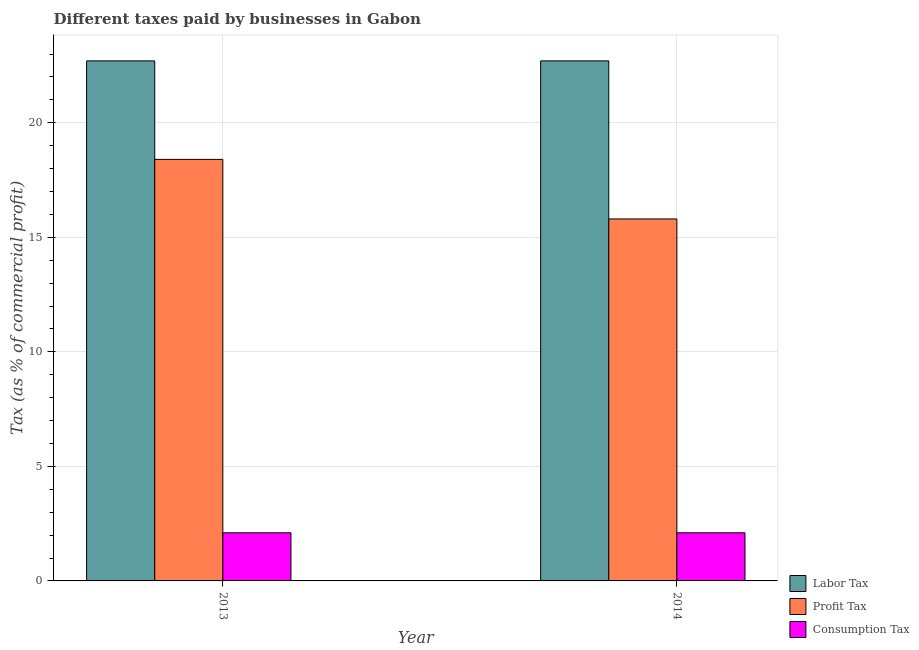How many different coloured bars are there?
Offer a very short reply. 3. How many groups of bars are there?
Your answer should be compact. 2. Are the number of bars on each tick of the X-axis equal?
Give a very brief answer. Yes. How many bars are there on the 2nd tick from the left?
Ensure brevity in your answer.  3. In how many cases, is the number of bars for a given year not equal to the number of legend labels?
Keep it short and to the point. 0. What is the percentage of consumption tax in 2014?
Offer a terse response. 2.1. Across all years, what is the maximum percentage of consumption tax?
Keep it short and to the point. 2.1. What is the total percentage of profit tax in the graph?
Offer a very short reply. 34.2. What is the difference between the percentage of profit tax in 2013 and that in 2014?
Ensure brevity in your answer.  2.6. What is the average percentage of consumption tax per year?
Give a very brief answer. 2.1. In how many years, is the percentage of profit tax greater than 11 %?
Offer a terse response. 2. What is the ratio of the percentage of profit tax in 2013 to that in 2014?
Make the answer very short. 1.16. What does the 2nd bar from the left in 2013 represents?
Give a very brief answer. Profit Tax. What does the 1st bar from the right in 2013 represents?
Give a very brief answer. Consumption Tax. How many bars are there?
Keep it short and to the point. 6. Are all the bars in the graph horizontal?
Offer a very short reply. No. How many years are there in the graph?
Ensure brevity in your answer.  2. What is the difference between two consecutive major ticks on the Y-axis?
Your response must be concise. 5. Does the graph contain grids?
Your response must be concise. Yes. Where does the legend appear in the graph?
Your response must be concise. Bottom right. How many legend labels are there?
Ensure brevity in your answer.  3. What is the title of the graph?
Provide a succinct answer. Different taxes paid by businesses in Gabon. Does "Social Insurance" appear as one of the legend labels in the graph?
Provide a succinct answer. No. What is the label or title of the Y-axis?
Offer a terse response. Tax (as % of commercial profit). What is the Tax (as % of commercial profit) in Labor Tax in 2013?
Your answer should be compact. 22.7. What is the Tax (as % of commercial profit) in Profit Tax in 2013?
Ensure brevity in your answer.  18.4. What is the Tax (as % of commercial profit) in Consumption Tax in 2013?
Provide a succinct answer. 2.1. What is the Tax (as % of commercial profit) of Labor Tax in 2014?
Keep it short and to the point. 22.7. What is the Tax (as % of commercial profit) of Consumption Tax in 2014?
Provide a succinct answer. 2.1. Across all years, what is the maximum Tax (as % of commercial profit) in Labor Tax?
Keep it short and to the point. 22.7. Across all years, what is the maximum Tax (as % of commercial profit) of Consumption Tax?
Give a very brief answer. 2.1. Across all years, what is the minimum Tax (as % of commercial profit) in Labor Tax?
Make the answer very short. 22.7. Across all years, what is the minimum Tax (as % of commercial profit) in Profit Tax?
Offer a very short reply. 15.8. What is the total Tax (as % of commercial profit) in Labor Tax in the graph?
Offer a terse response. 45.4. What is the total Tax (as % of commercial profit) of Profit Tax in the graph?
Offer a very short reply. 34.2. What is the total Tax (as % of commercial profit) of Consumption Tax in the graph?
Provide a succinct answer. 4.2. What is the difference between the Tax (as % of commercial profit) of Labor Tax in 2013 and that in 2014?
Offer a terse response. 0. What is the difference between the Tax (as % of commercial profit) of Profit Tax in 2013 and that in 2014?
Keep it short and to the point. 2.6. What is the difference between the Tax (as % of commercial profit) in Consumption Tax in 2013 and that in 2014?
Make the answer very short. 0. What is the difference between the Tax (as % of commercial profit) of Labor Tax in 2013 and the Tax (as % of commercial profit) of Profit Tax in 2014?
Make the answer very short. 6.9. What is the difference between the Tax (as % of commercial profit) of Labor Tax in 2013 and the Tax (as % of commercial profit) of Consumption Tax in 2014?
Your answer should be compact. 20.6. What is the difference between the Tax (as % of commercial profit) in Profit Tax in 2013 and the Tax (as % of commercial profit) in Consumption Tax in 2014?
Make the answer very short. 16.3. What is the average Tax (as % of commercial profit) of Labor Tax per year?
Keep it short and to the point. 22.7. What is the average Tax (as % of commercial profit) in Profit Tax per year?
Your answer should be very brief. 17.1. What is the average Tax (as % of commercial profit) of Consumption Tax per year?
Keep it short and to the point. 2.1. In the year 2013, what is the difference between the Tax (as % of commercial profit) in Labor Tax and Tax (as % of commercial profit) in Consumption Tax?
Provide a short and direct response. 20.6. In the year 2013, what is the difference between the Tax (as % of commercial profit) of Profit Tax and Tax (as % of commercial profit) of Consumption Tax?
Provide a succinct answer. 16.3. In the year 2014, what is the difference between the Tax (as % of commercial profit) of Labor Tax and Tax (as % of commercial profit) of Profit Tax?
Offer a terse response. 6.9. In the year 2014, what is the difference between the Tax (as % of commercial profit) of Labor Tax and Tax (as % of commercial profit) of Consumption Tax?
Ensure brevity in your answer.  20.6. In the year 2014, what is the difference between the Tax (as % of commercial profit) in Profit Tax and Tax (as % of commercial profit) in Consumption Tax?
Offer a terse response. 13.7. What is the ratio of the Tax (as % of commercial profit) in Profit Tax in 2013 to that in 2014?
Your answer should be compact. 1.16. What is the ratio of the Tax (as % of commercial profit) of Consumption Tax in 2013 to that in 2014?
Keep it short and to the point. 1. What is the difference between the highest and the second highest Tax (as % of commercial profit) of Labor Tax?
Offer a terse response. 0. What is the difference between the highest and the second highest Tax (as % of commercial profit) in Profit Tax?
Your answer should be very brief. 2.6. What is the difference between the highest and the second highest Tax (as % of commercial profit) of Consumption Tax?
Provide a succinct answer. 0. What is the difference between the highest and the lowest Tax (as % of commercial profit) in Labor Tax?
Ensure brevity in your answer.  0. 